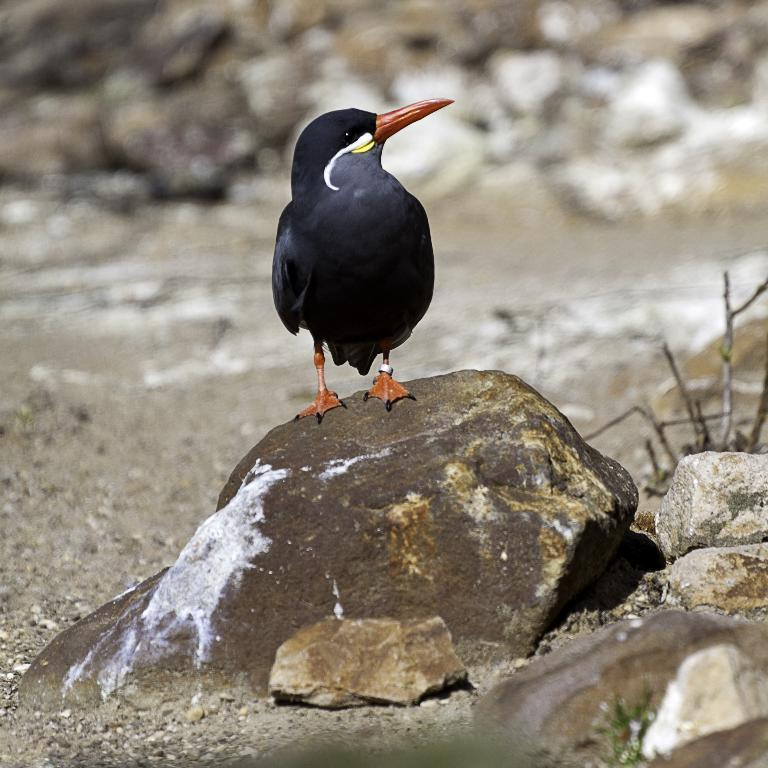What type of animal is in the image? There is a black bird in the image. Where is the bird located? The bird is on a rock. Can you describe the background of the image? The background of the image is blurred. What else can be seen in the image besides the bird? There are rocks in front of the bird. What type of celery is the bird eating in the image? There is no celery present in the image, and the bird is not eating anything. 